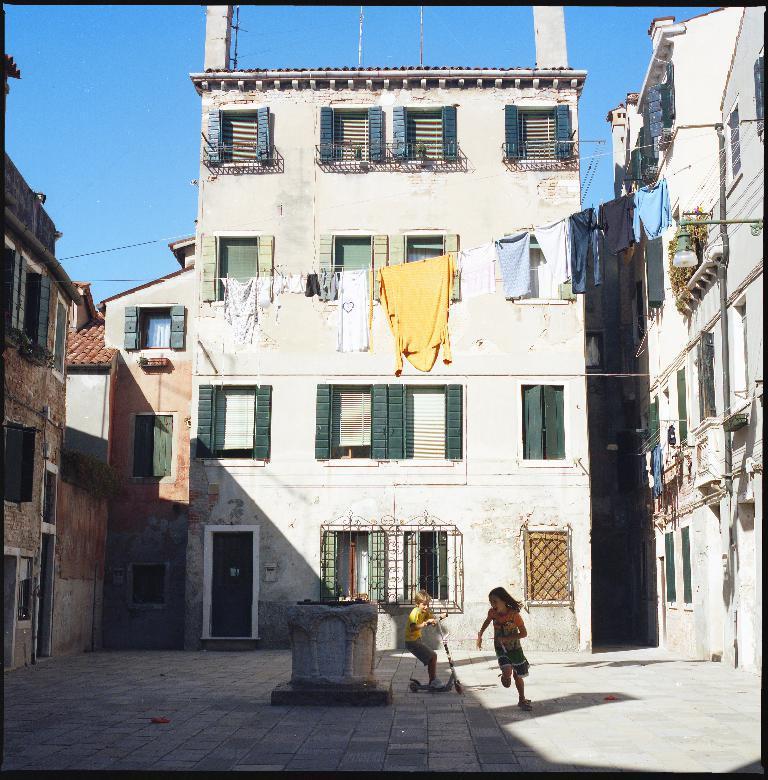How would you summarize this image in a sentence or two? There are two kids playing as we can see at the bottom of this image, and there are some buildings in the background. There are some clothes hanging on the rope in the middle of this image, and there is a blue sky at the top of this image. 